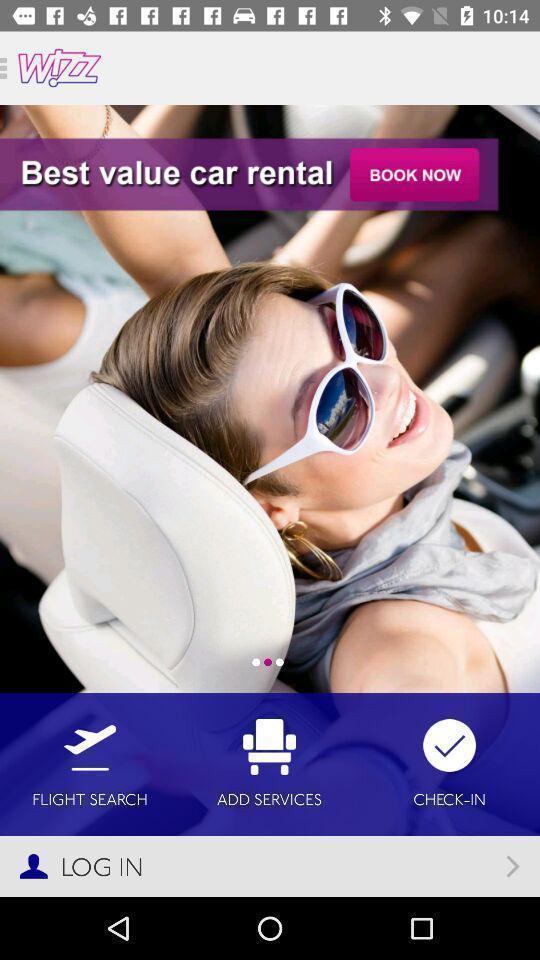Tell me about the visual elements in this screen capture. Login page of a car rental and flight search app. 